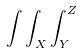<formula> <loc_0><loc_0><loc_500><loc_500>\int \int _ { X } \int _ { Y } ^ { Z }</formula> 